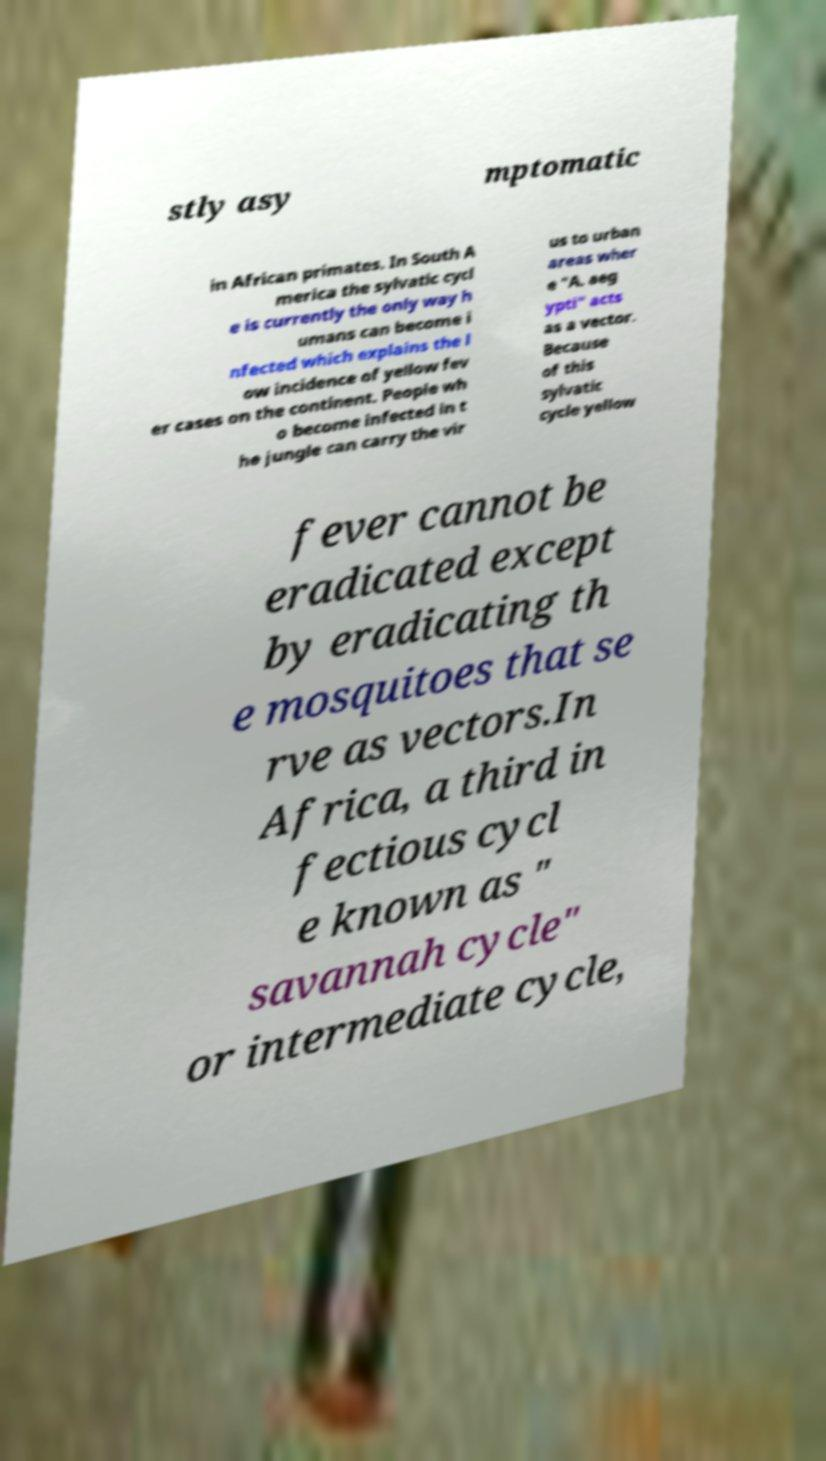Please read and relay the text visible in this image. What does it say? stly asy mptomatic in African primates. In South A merica the sylvatic cycl e is currently the only way h umans can become i nfected which explains the l ow incidence of yellow fev er cases on the continent. People wh o become infected in t he jungle can carry the vir us to urban areas wher e "A. aeg ypti" acts as a vector. Because of this sylvatic cycle yellow fever cannot be eradicated except by eradicating th e mosquitoes that se rve as vectors.In Africa, a third in fectious cycl e known as " savannah cycle" or intermediate cycle, 